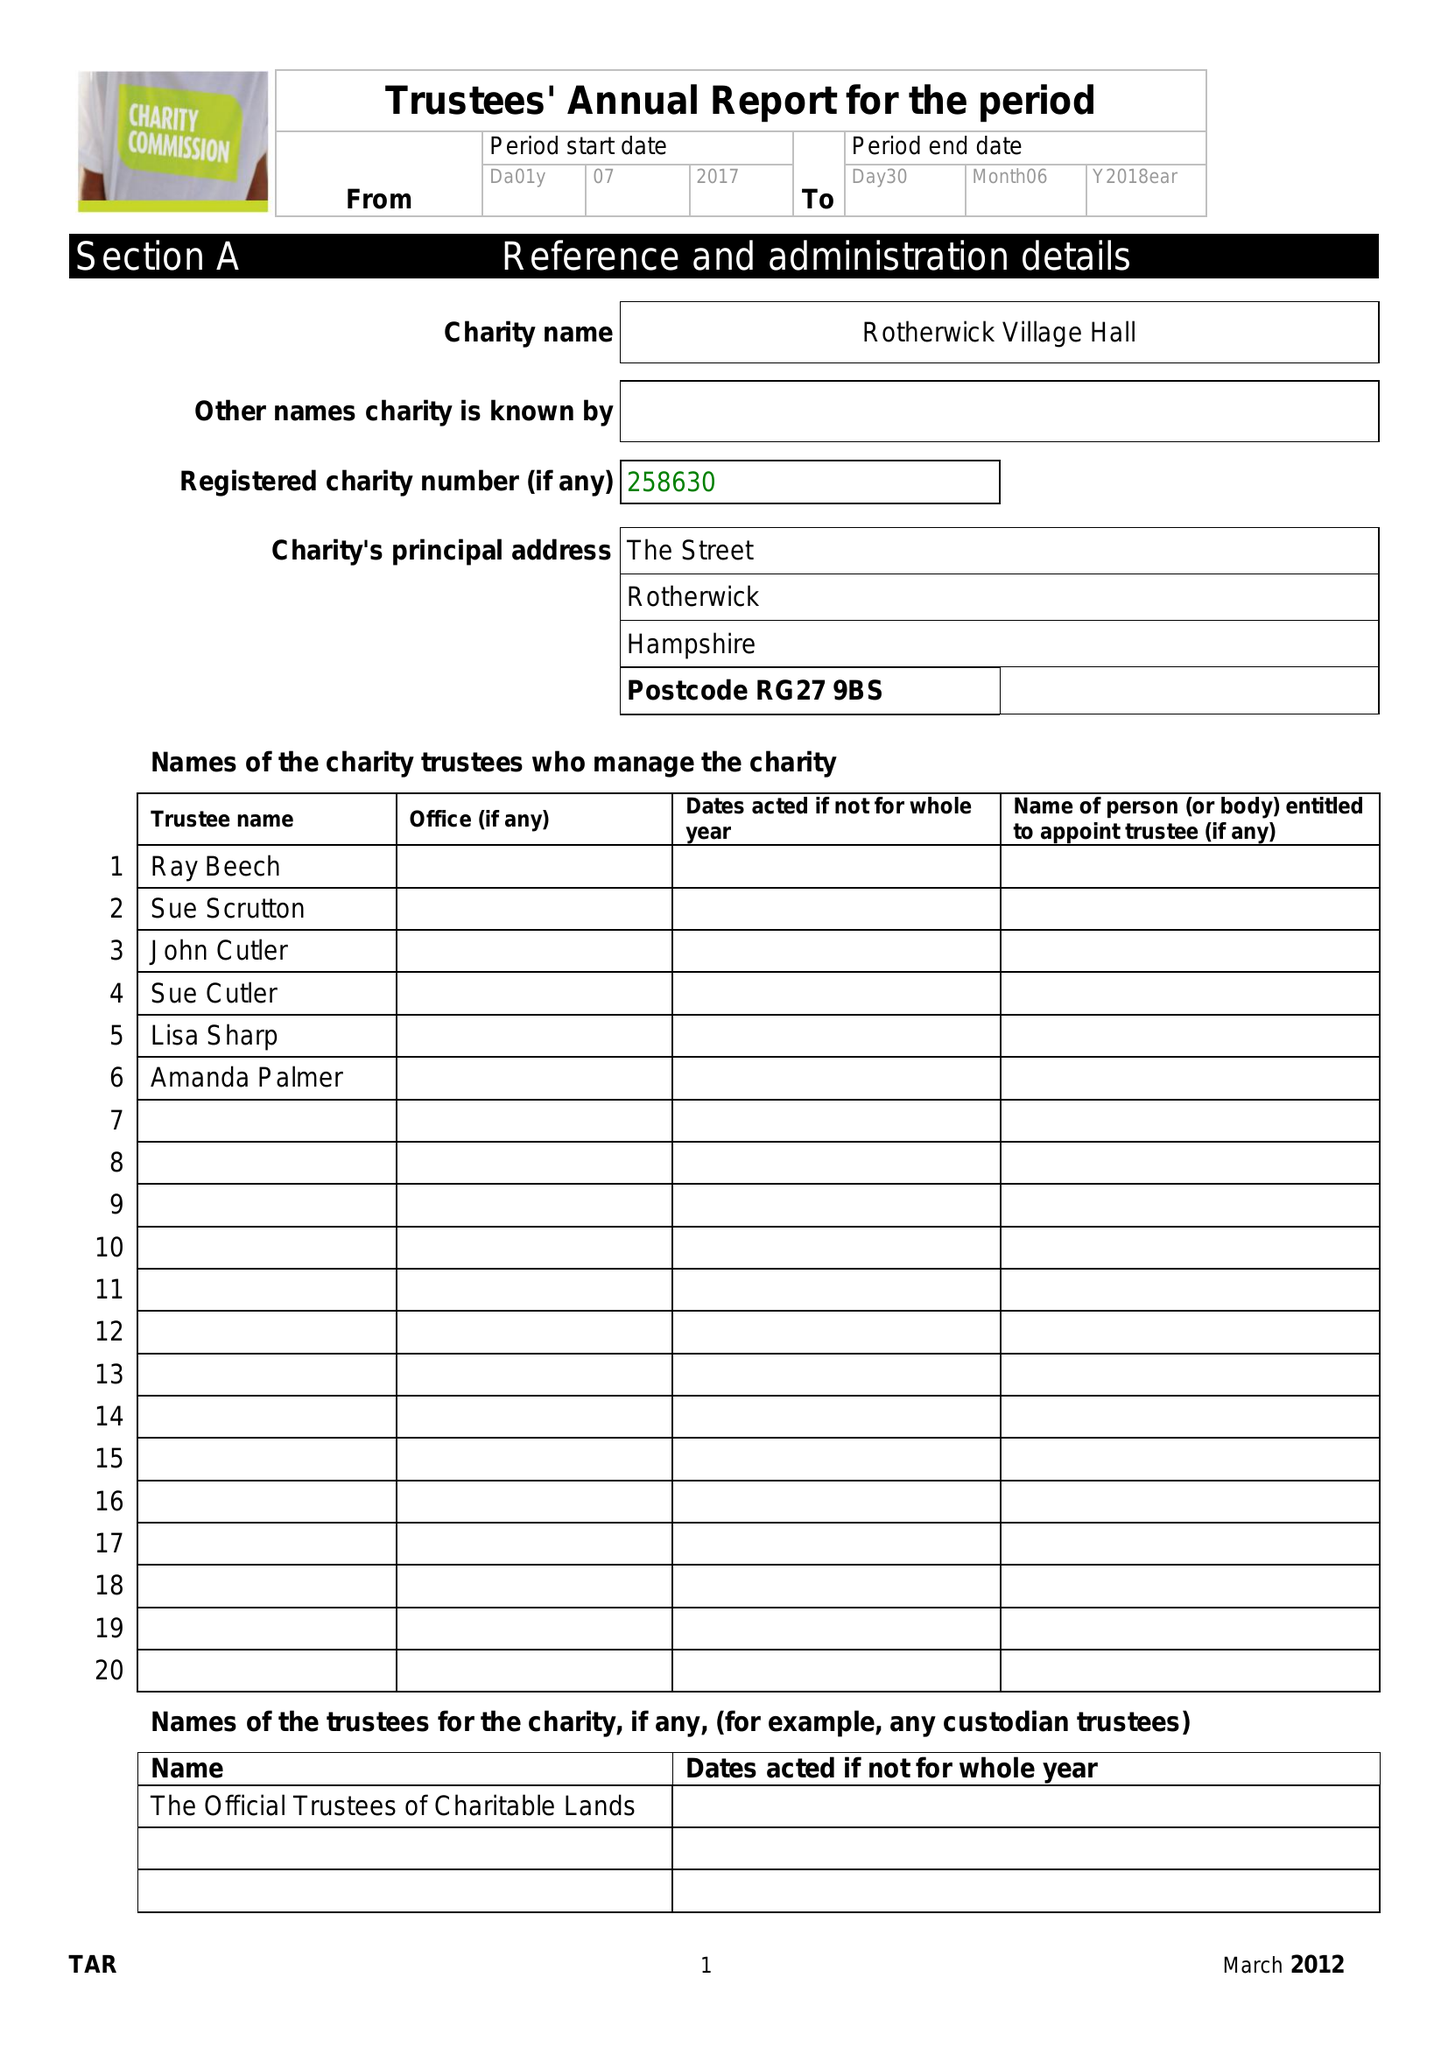What is the value for the address__post_town?
Answer the question using a single word or phrase. HOOK 